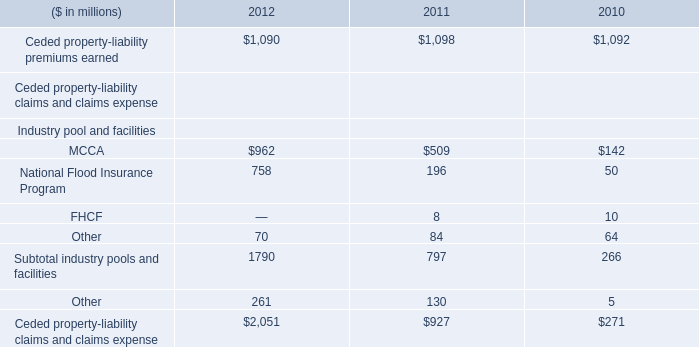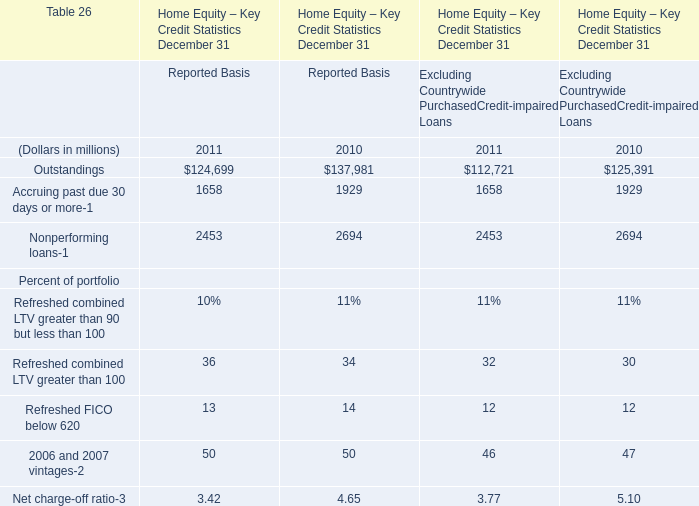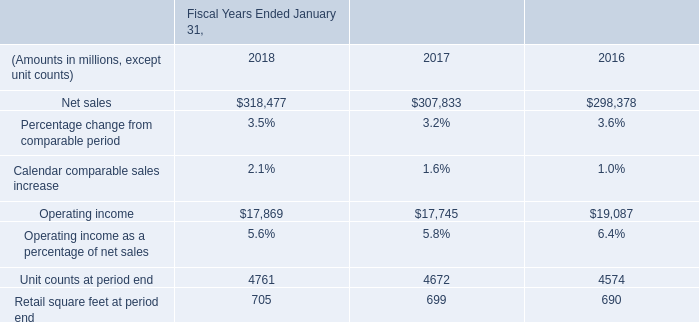in fiscal 2017 what was the ratio of the gain from the sale of the yihaodian business to the gain from the sale of shopping malls in chile . 
Computations: (535 / 194)
Answer: 2.75773. 